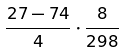<formula> <loc_0><loc_0><loc_500><loc_500>\frac { 2 7 - 7 4 } { 4 } \cdot \frac { 8 } { 2 9 8 }</formula> 